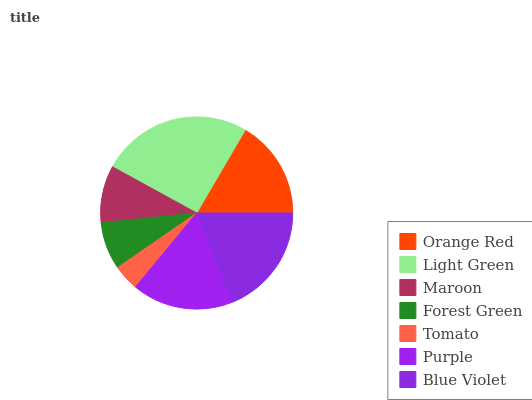Is Tomato the minimum?
Answer yes or no. Yes. Is Light Green the maximum?
Answer yes or no. Yes. Is Maroon the minimum?
Answer yes or no. No. Is Maroon the maximum?
Answer yes or no. No. Is Light Green greater than Maroon?
Answer yes or no. Yes. Is Maroon less than Light Green?
Answer yes or no. Yes. Is Maroon greater than Light Green?
Answer yes or no. No. Is Light Green less than Maroon?
Answer yes or no. No. Is Orange Red the high median?
Answer yes or no. Yes. Is Orange Red the low median?
Answer yes or no. Yes. Is Forest Green the high median?
Answer yes or no. No. Is Forest Green the low median?
Answer yes or no. No. 